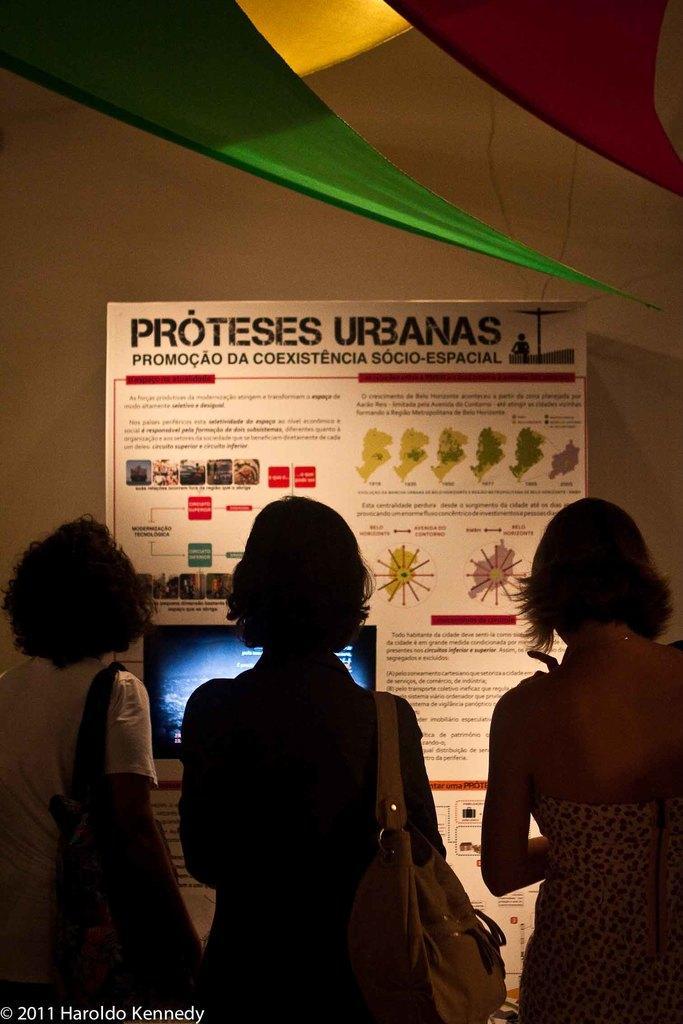Can you describe this image briefly? The picture taken in a room. In the foreground of the picture there are three women, the three women are wearing handbags. In the center of the picture there is a board. In the background it is well. 